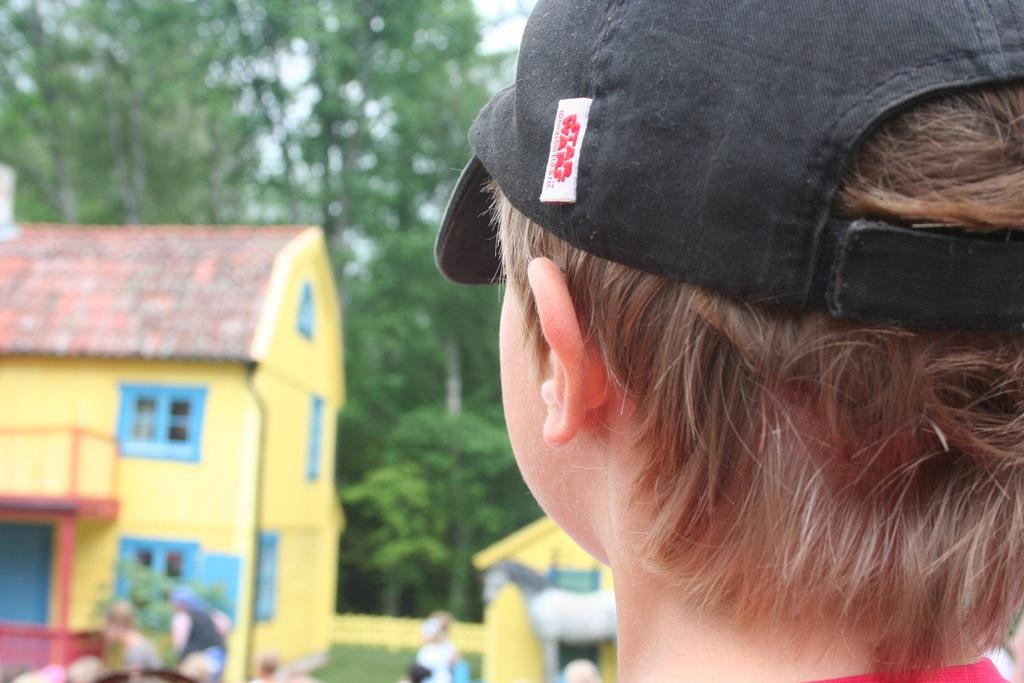What is the person in the image wearing on their head? The person in the image is wearing a cap. What can be seen in the distance behind the person? There are houses, other persons, trees, the sky, and other objects in the background of the image. Can you describe the environment in the background of the image? The background of the image features a residential area with houses, trees, and the sky visible. What type of grass is growing on the seat in the image? There is no grass or seat present in the image. 